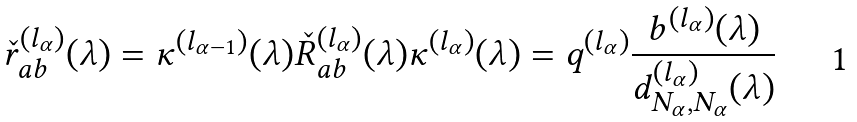Convert formula to latex. <formula><loc_0><loc_0><loc_500><loc_500>\check { r } _ { a b } ^ { ( l _ { \alpha } ) } ( \lambda ) = { \kappa } ^ { ( l _ { \alpha - 1 } ) } ( \lambda ) \check { R } _ { a b } ^ { ( l _ { \alpha } ) } ( \lambda ) { \kappa } ^ { ( l _ { \alpha } ) } ( \lambda ) = q ^ { ( l _ { \alpha } ) } \frac { b ^ { ( l _ { \alpha } ) } ( \lambda ) } { d _ { N _ { \alpha } , N _ { \alpha } } ^ { ( l _ { \alpha } ) } ( \lambda ) }</formula> 